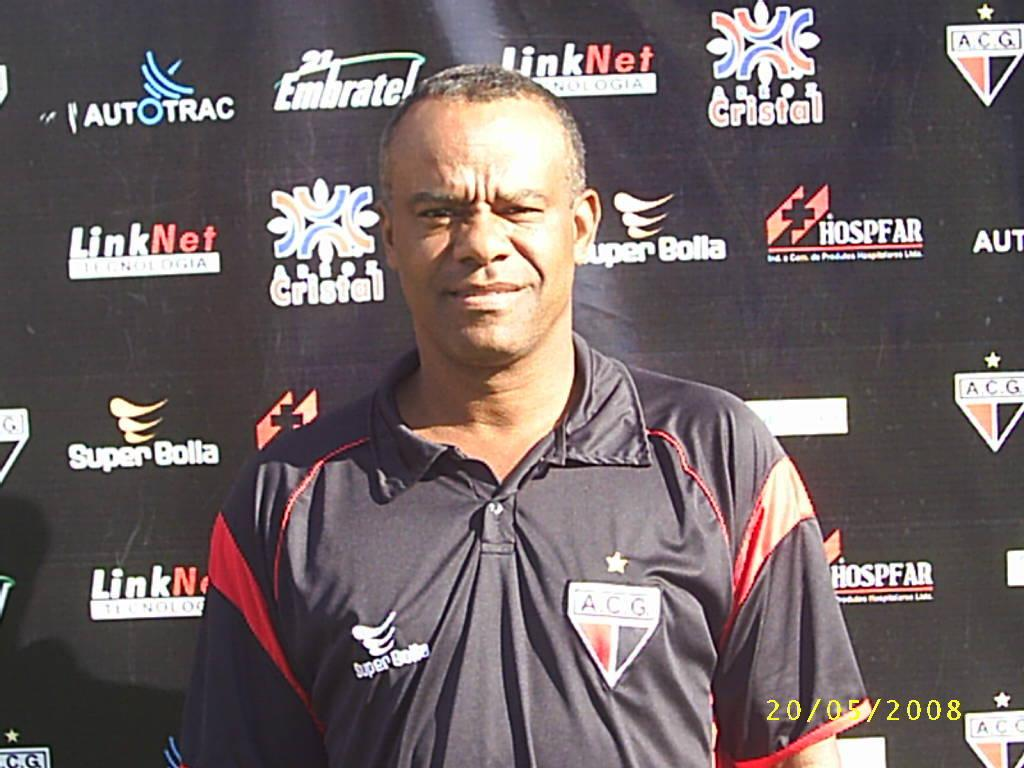<image>
Render a clear and concise summary of the photo. The man's black shirt has a patch with A.C.G. on it. 